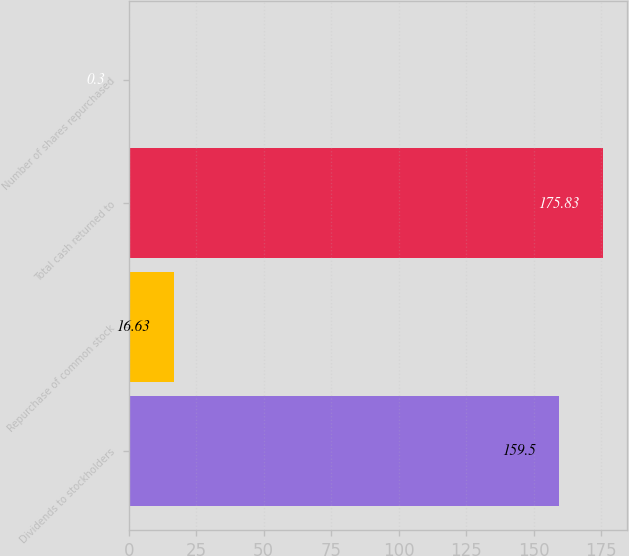Convert chart. <chart><loc_0><loc_0><loc_500><loc_500><bar_chart><fcel>Dividends to stockholders<fcel>Repurchase of common stock<fcel>Total cash returned to<fcel>Number of shares repurchased<nl><fcel>159.5<fcel>16.63<fcel>175.83<fcel>0.3<nl></chart> 